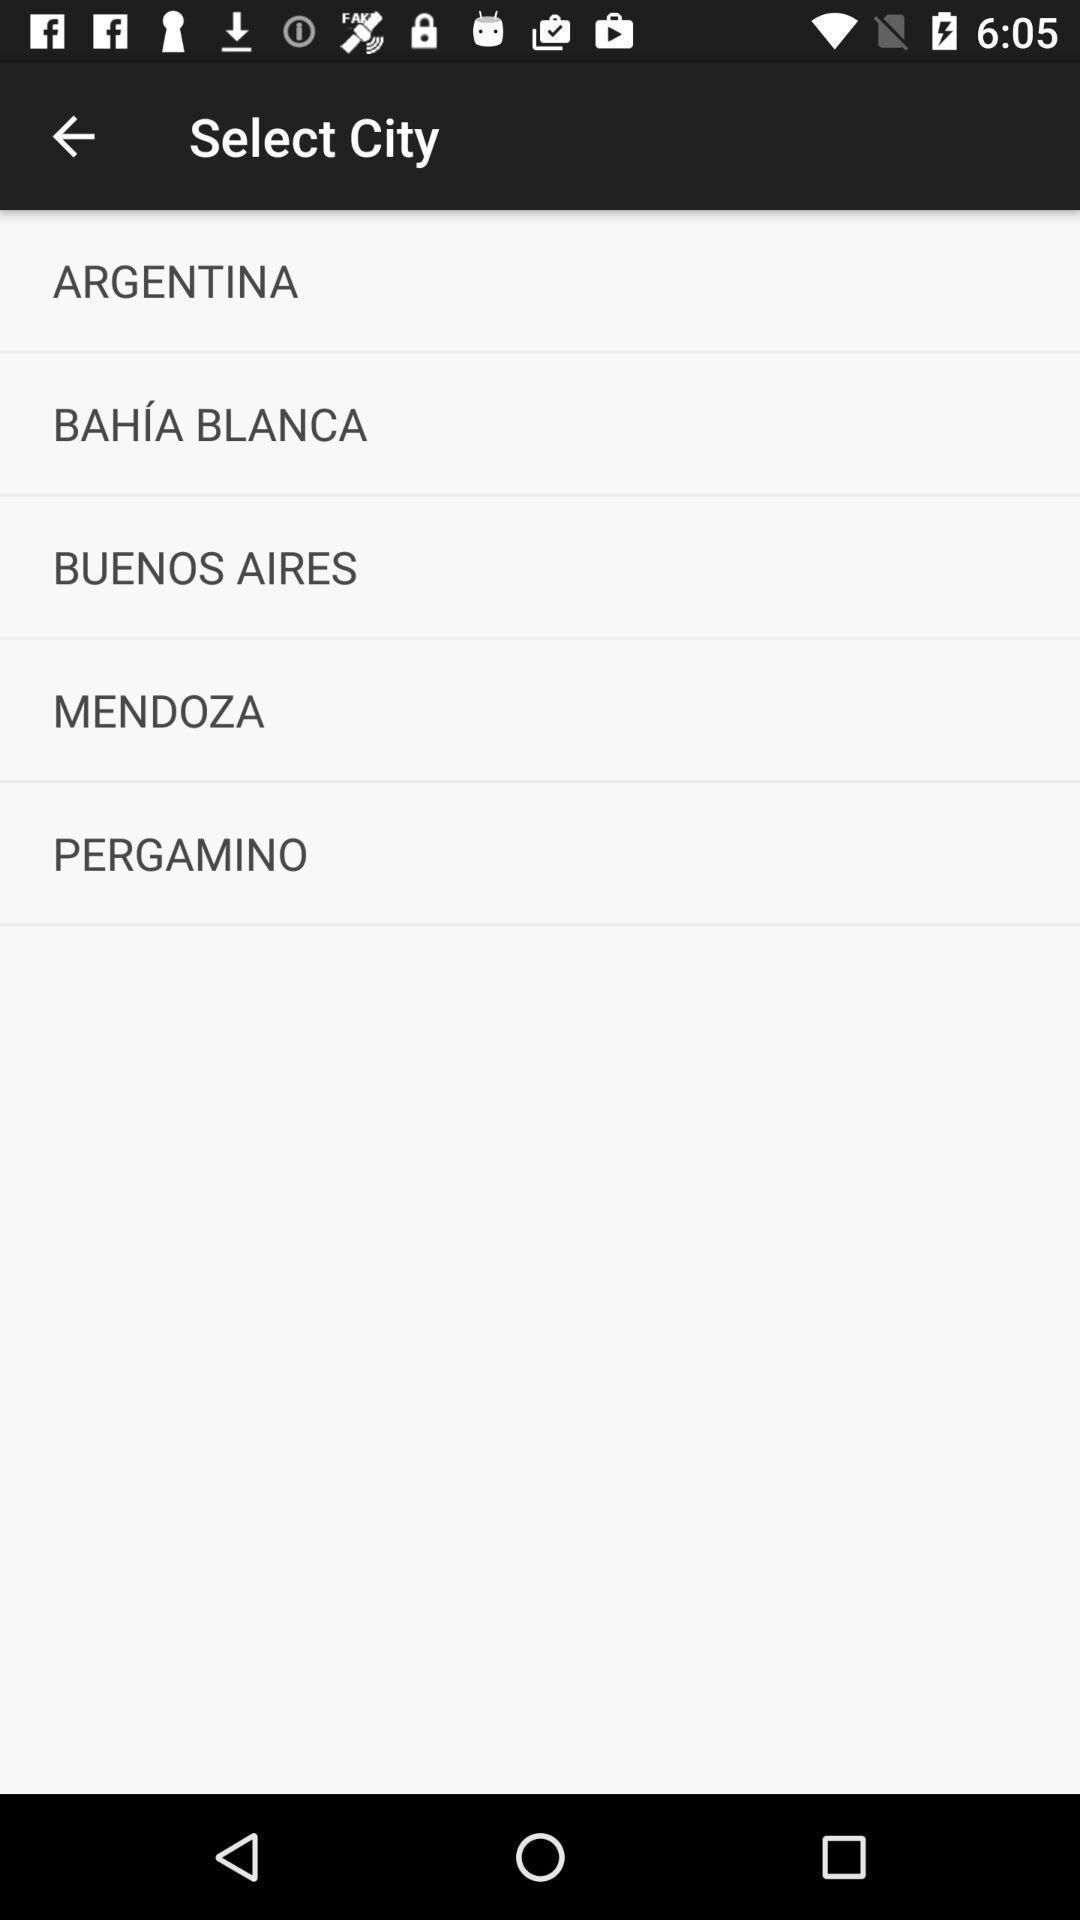Explain what's happening in this screen capture. Page displaying various cities. 